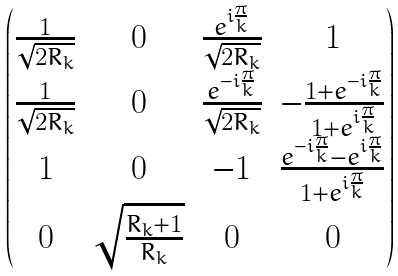Convert formula to latex. <formula><loc_0><loc_0><loc_500><loc_500>\begin{pmatrix} \frac { 1 } { \sqrt { 2 R _ { k } } } & 0 & \frac { e ^ { i \frac { \pi } { k } } } { \sqrt { 2 R _ { k } } } & 1 \\ \frac { 1 } { \sqrt { 2 R _ { k } } } & 0 & \frac { e ^ { - i \frac { \pi } { k } } } { \sqrt { 2 R _ { k } } } & - \frac { 1 + e ^ { - i \frac { \pi } { k } } } { 1 + e ^ { i \frac { \pi } { k } } } \\ 1 & 0 & - 1 & \frac { e ^ { - i \frac { \pi } { k } } - e ^ { i \frac { \pi } { k } } } { 1 + e ^ { i \frac { \pi } { k } } } \\ 0 & \sqrt { \frac { R _ { k } + 1 } { R _ { k } } } & 0 & 0 \end{pmatrix}</formula> 